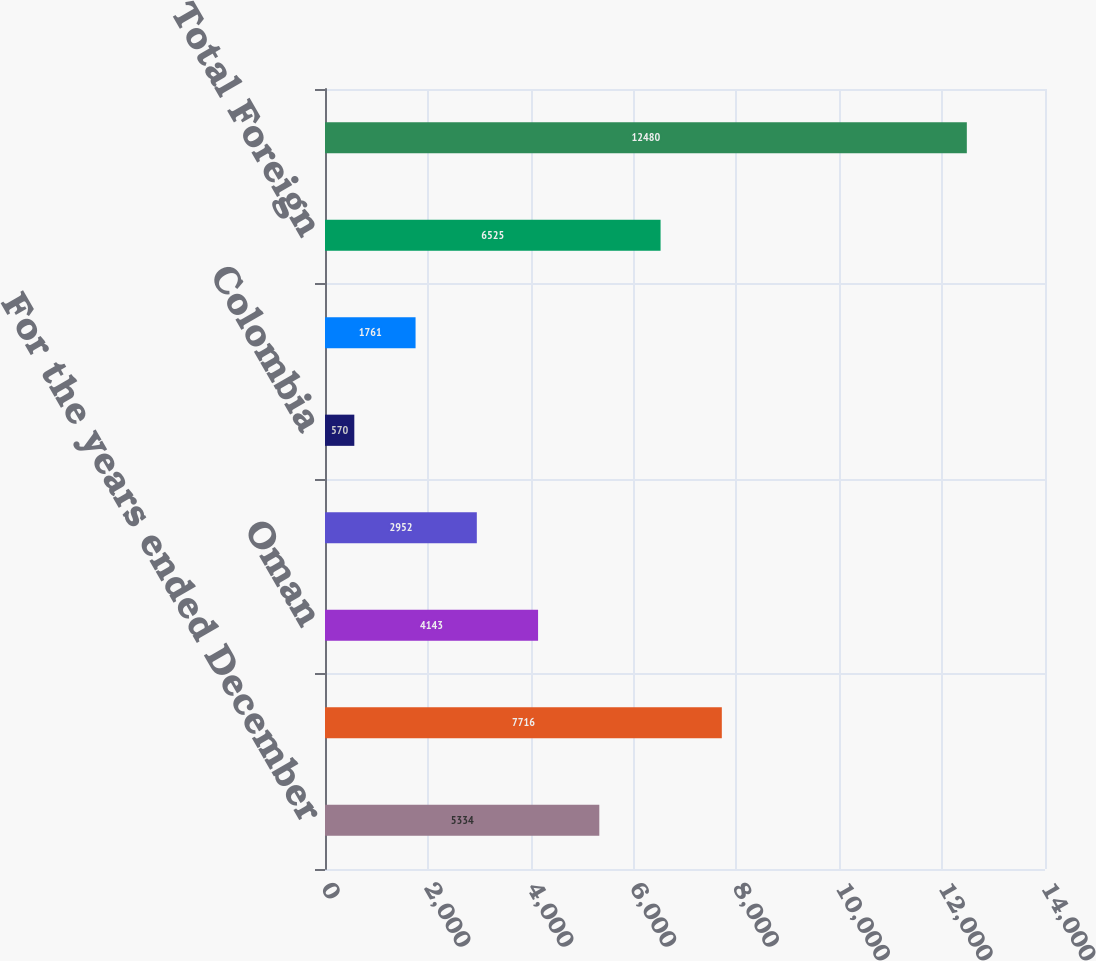<chart> <loc_0><loc_0><loc_500><loc_500><bar_chart><fcel>For the years ended December<fcel>United States<fcel>Oman<fcel>Qatar<fcel>Colombia<fcel>Other Foreign<fcel>Total Foreign<fcel>Total<nl><fcel>5334<fcel>7716<fcel>4143<fcel>2952<fcel>570<fcel>1761<fcel>6525<fcel>12480<nl></chart> 